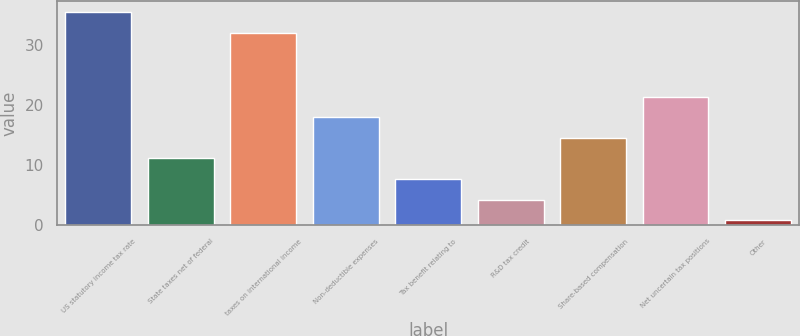Convert chart. <chart><loc_0><loc_0><loc_500><loc_500><bar_chart><fcel>US statutory income tax rate<fcel>State taxes net of federal<fcel>taxes on international income<fcel>Non-deductible expenses<fcel>Tax benefit relating to<fcel>R&D tax credit<fcel>Share-based compensation<fcel>Net uncertain tax positions<fcel>Other<nl><fcel>35.42<fcel>11.06<fcel>32<fcel>17.9<fcel>7.64<fcel>4.22<fcel>14.48<fcel>21.32<fcel>0.8<nl></chart> 